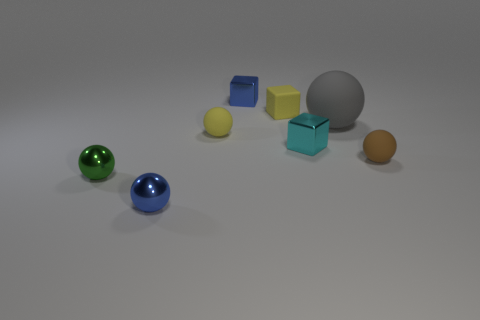Subtract all blue balls. How many balls are left? 4 Subtract 2 balls. How many balls are left? 3 Subtract all brown spheres. How many spheres are left? 4 Subtract all green blocks. Subtract all cyan cylinders. How many blocks are left? 3 Add 2 cyan metal blocks. How many objects exist? 10 Subtract all spheres. How many objects are left? 3 Subtract 0 gray cylinders. How many objects are left? 8 Subtract all small metal balls. Subtract all cyan blocks. How many objects are left? 5 Add 4 tiny yellow cubes. How many tiny yellow cubes are left? 5 Add 4 large gray metallic blocks. How many large gray metallic blocks exist? 4 